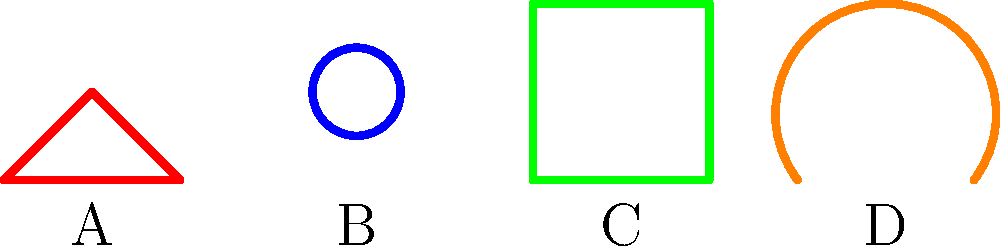As a nonprofit coordinator overseeing digital art production, you are analyzing different digital art styles. The image above shows four icons representing various artistic approaches. Which icon best represents the fluid, organic style often associated with digital painting and illustration? Let's analyze each icon to determine which best represents the fluid, organic style often associated with digital painting and illustration:

1. Icon A: This icon shows a triangular shape with straight lines. It represents a more geometric, sharp-edged style, which is not typically associated with fluid, organic forms.

2. Icon B: This icon is a perfect circle. While circles can be considered organic, this particular representation is too precise and geometric to best represent the fluid nature of digital painting.

3. Icon C: This icon is a square or rectangle with straight edges. Like Icon A, it represents a more rigid, geometric style that doesn't align with fluid, organic forms.

4. Icon D: This icon shows a curved line that flows from one side to the other, creating a wave-like shape. This curvilinear form best represents the fluid, organic style often seen in digital painting and illustration. The smooth, continuous curve mimics the natural, flowing lines that artists can achieve with digital brushes and tools.

Given these observations, Icon D is the best representation of the fluid, organic style often associated with digital painting and illustration. Its curvy, flowing shape aligns most closely with the natural, organic forms that digital artists often create in their work.
Answer: D 